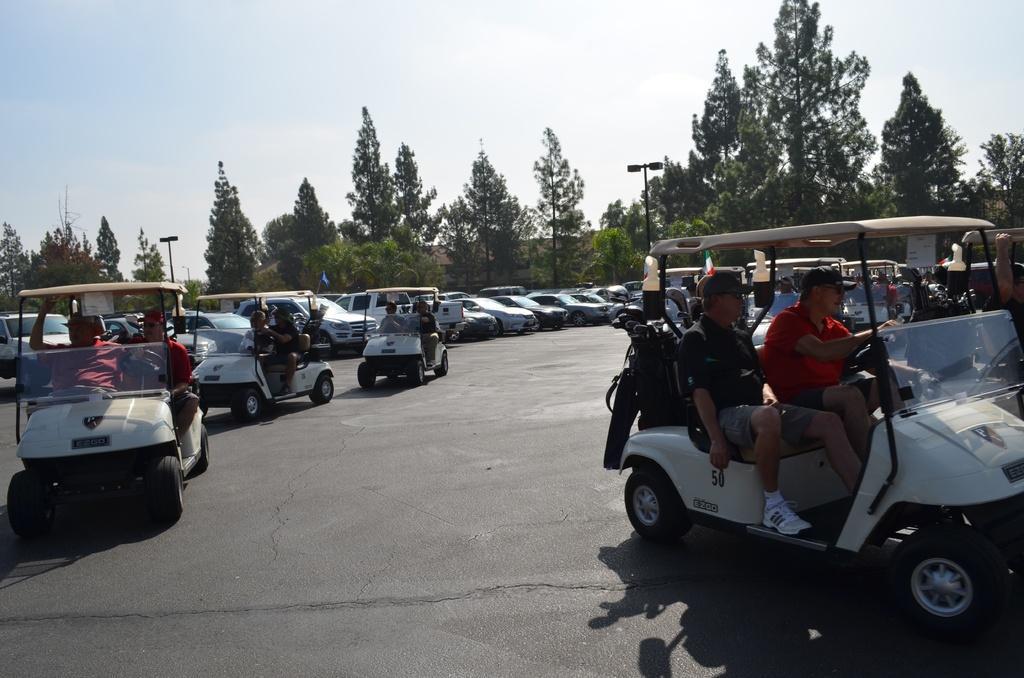In one or two sentences, can you explain what this image depicts? In this picture there are some white color electric cars in which some person are sitting and riding. Behind there are many cars are parked in the ground. In the background there are many trees and street poles. 